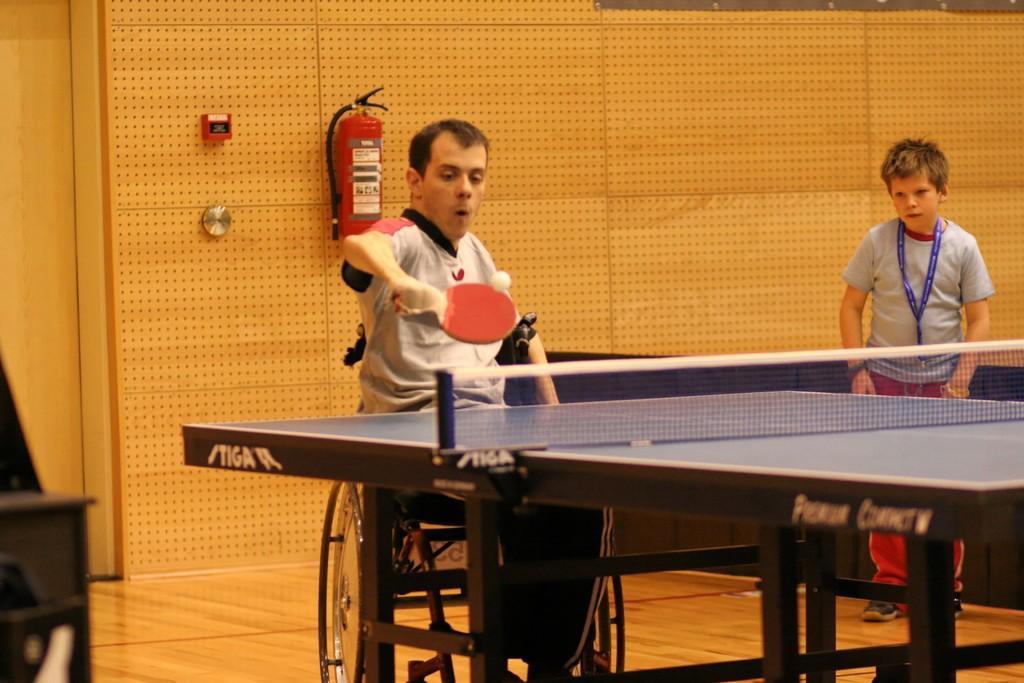Could you give a brief overview of what you see in this image? In this image in the center there is one person who is sitting on wheelchair, and he is playing table tennis. In front of him there is table, net and on the right side there is one boy standing. In the background there is wall, on the wall there are some objects and on the left side there is some object. At the bottom there is floor. 